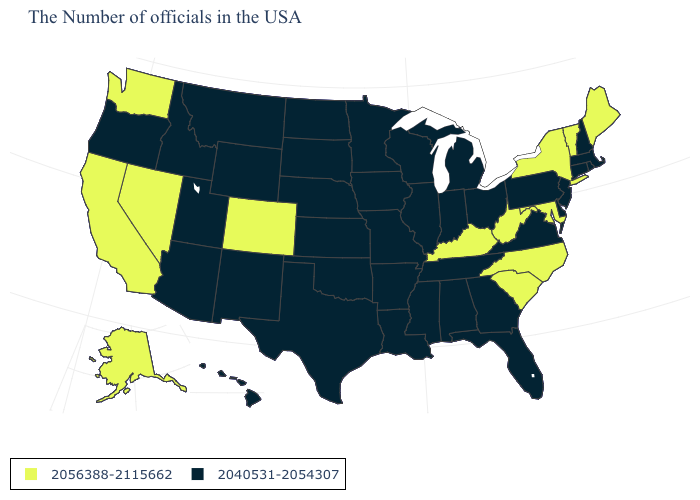What is the value of Tennessee?
Quick response, please. 2040531-2054307. Which states have the lowest value in the West?
Write a very short answer. Wyoming, New Mexico, Utah, Montana, Arizona, Idaho, Oregon, Hawaii. Does New Mexico have the lowest value in the West?
Give a very brief answer. Yes. Name the states that have a value in the range 2056388-2115662?
Answer briefly. Maine, Vermont, New York, Maryland, North Carolina, South Carolina, West Virginia, Kentucky, Colorado, Nevada, California, Washington, Alaska. What is the highest value in states that border Louisiana?
Short answer required. 2040531-2054307. Which states hav the highest value in the West?
Write a very short answer. Colorado, Nevada, California, Washington, Alaska. Which states have the lowest value in the South?
Keep it brief. Delaware, Virginia, Florida, Georgia, Alabama, Tennessee, Mississippi, Louisiana, Arkansas, Oklahoma, Texas. What is the lowest value in the South?
Short answer required. 2040531-2054307. What is the lowest value in the USA?
Write a very short answer. 2040531-2054307. Name the states that have a value in the range 2040531-2054307?
Answer briefly. Massachusetts, Rhode Island, New Hampshire, Connecticut, New Jersey, Delaware, Pennsylvania, Virginia, Ohio, Florida, Georgia, Michigan, Indiana, Alabama, Tennessee, Wisconsin, Illinois, Mississippi, Louisiana, Missouri, Arkansas, Minnesota, Iowa, Kansas, Nebraska, Oklahoma, Texas, South Dakota, North Dakota, Wyoming, New Mexico, Utah, Montana, Arizona, Idaho, Oregon, Hawaii. Name the states that have a value in the range 2056388-2115662?
Quick response, please. Maine, Vermont, New York, Maryland, North Carolina, South Carolina, West Virginia, Kentucky, Colorado, Nevada, California, Washington, Alaska. Which states hav the highest value in the South?
Answer briefly. Maryland, North Carolina, South Carolina, West Virginia, Kentucky. Among the states that border Arizona , which have the lowest value?
Give a very brief answer. New Mexico, Utah. 